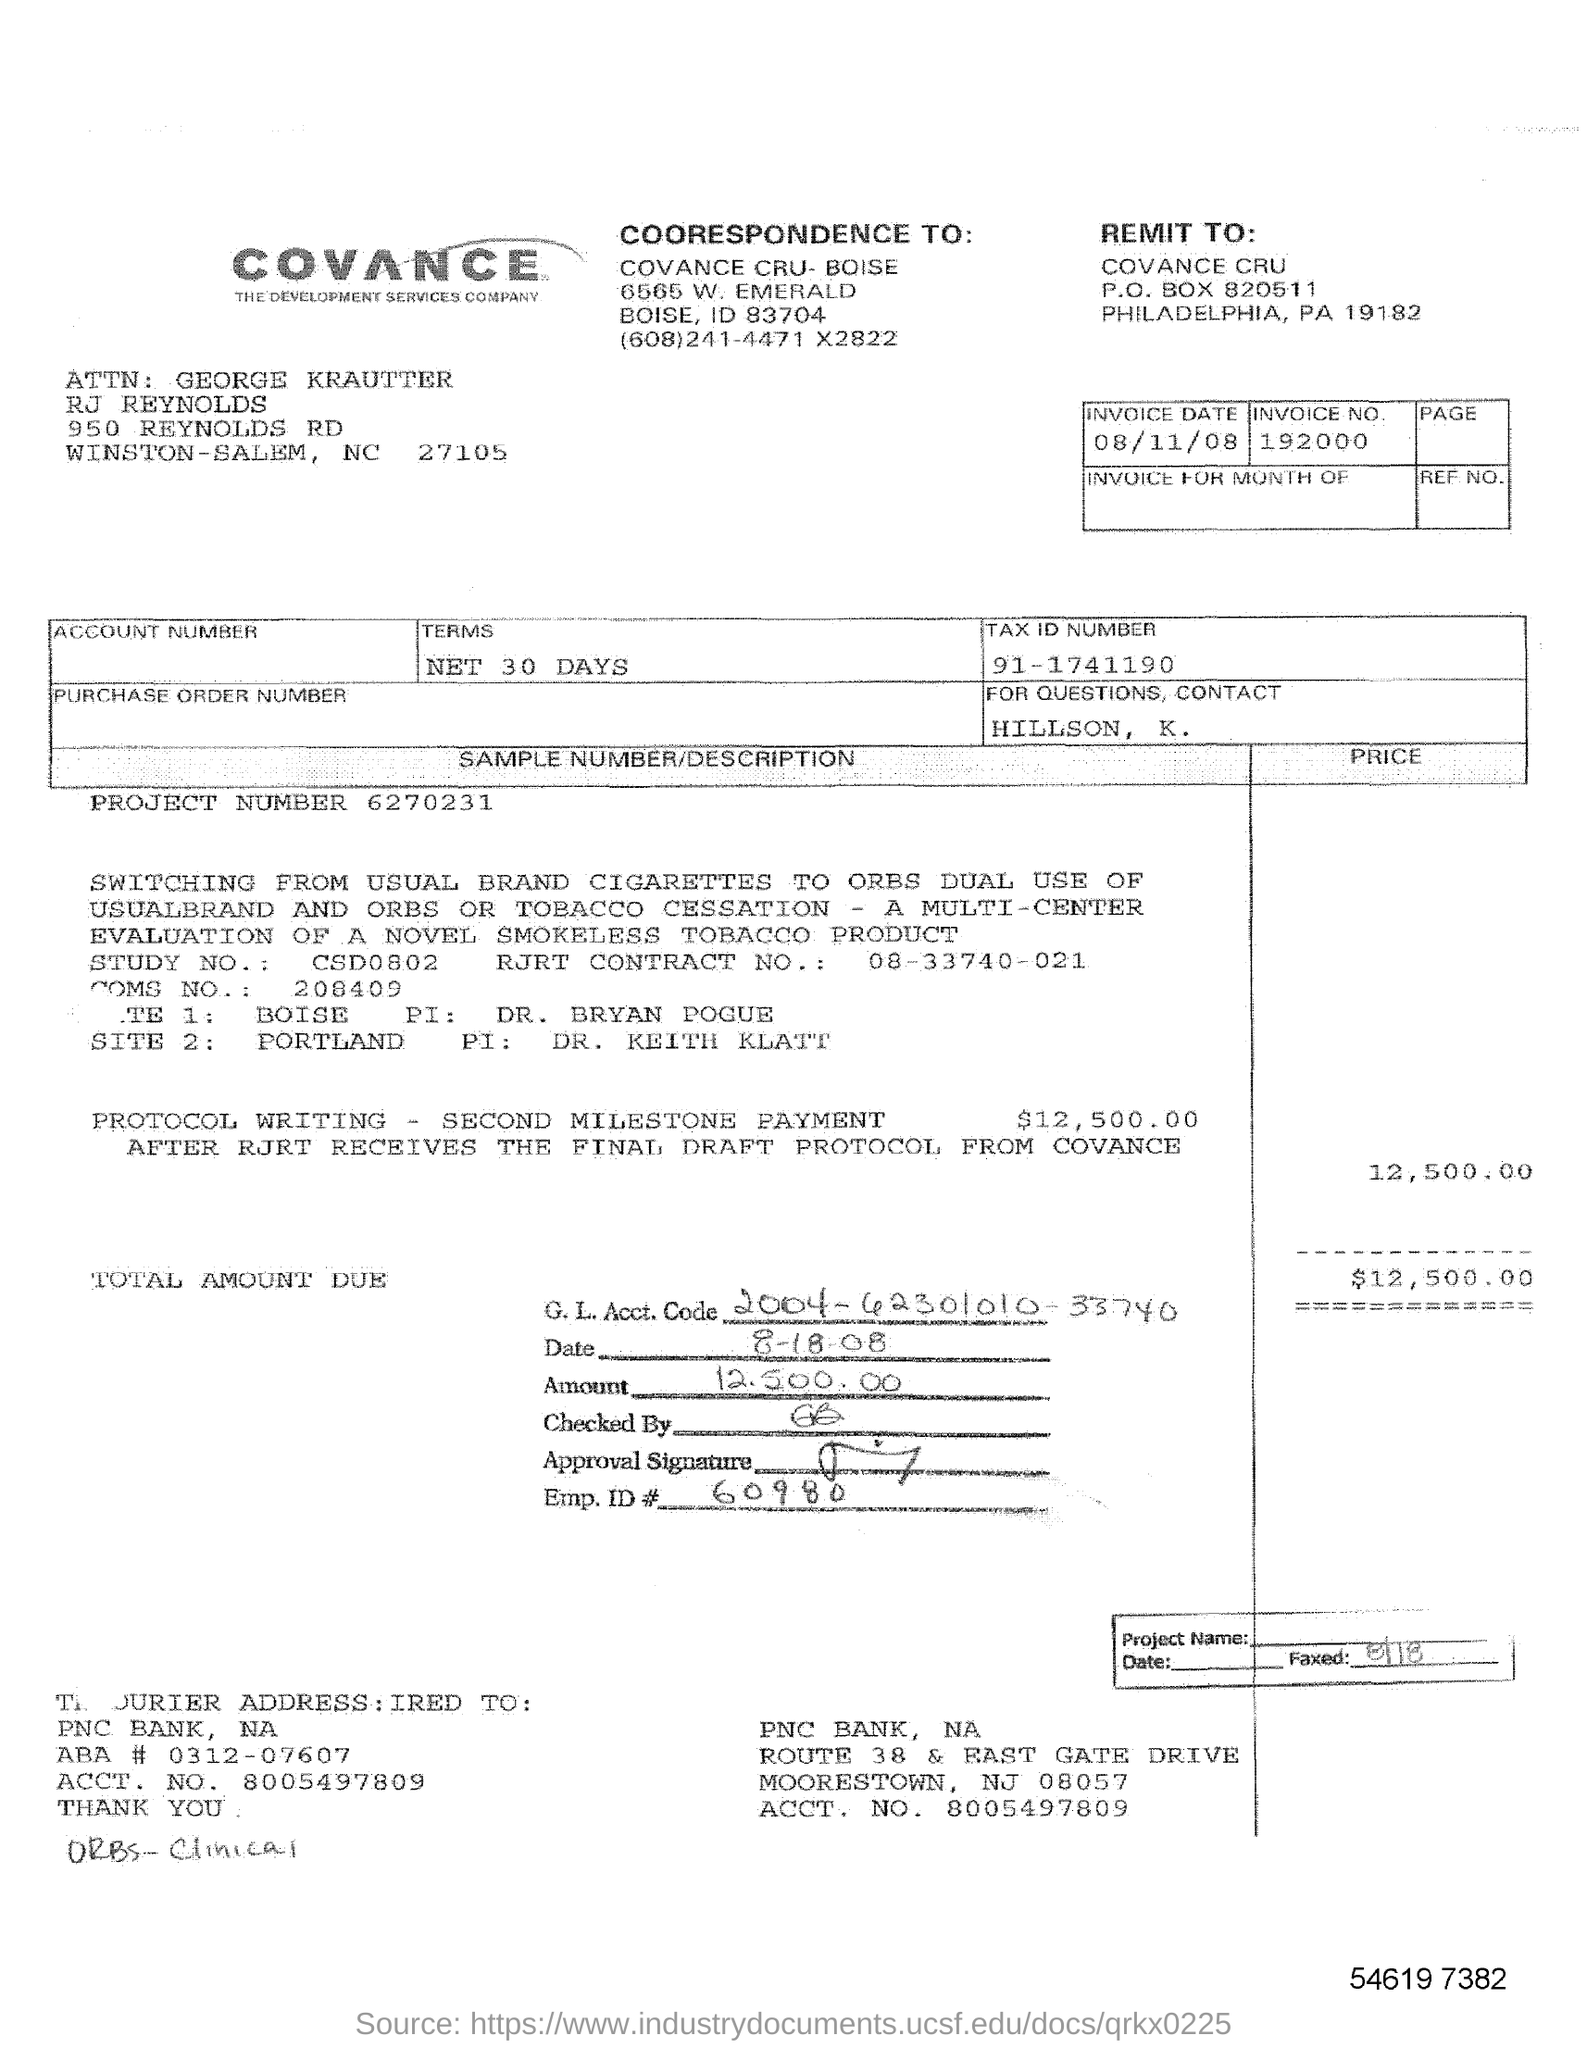Outline some significant characteristics in this image. The account number is 8005497809. What is the tax ID number? It is 911741190... Please provide the RJRT Contract number, which is 08-33740-021. The project number is 6270231... The representation "What is the Emp.ID? 60980.." is unclear and lacks context. Could you please provide more information or context so I can better understand your request? 